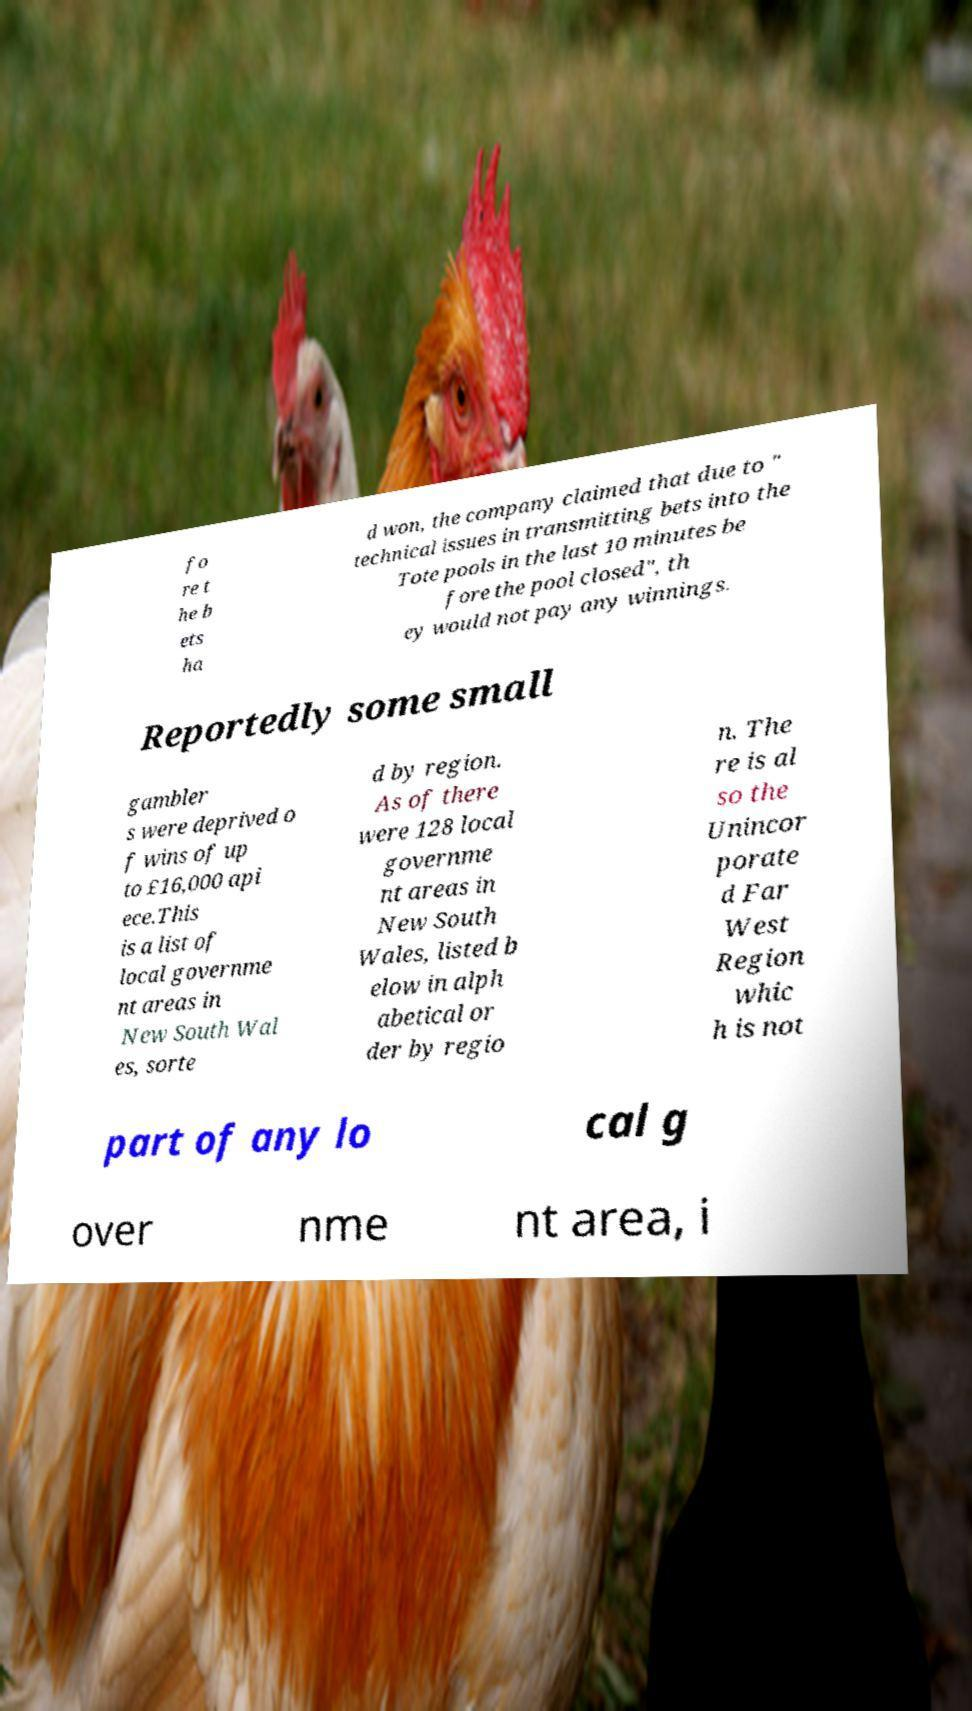Please read and relay the text visible in this image. What does it say? fo re t he b ets ha d won, the company claimed that due to " technical issues in transmitting bets into the Tote pools in the last 10 minutes be fore the pool closed", th ey would not pay any winnings. Reportedly some small gambler s were deprived o f wins of up to £16,000 api ece.This is a list of local governme nt areas in New South Wal es, sorte d by region. As of there were 128 local governme nt areas in New South Wales, listed b elow in alph abetical or der by regio n. The re is al so the Unincor porate d Far West Region whic h is not part of any lo cal g over nme nt area, i 